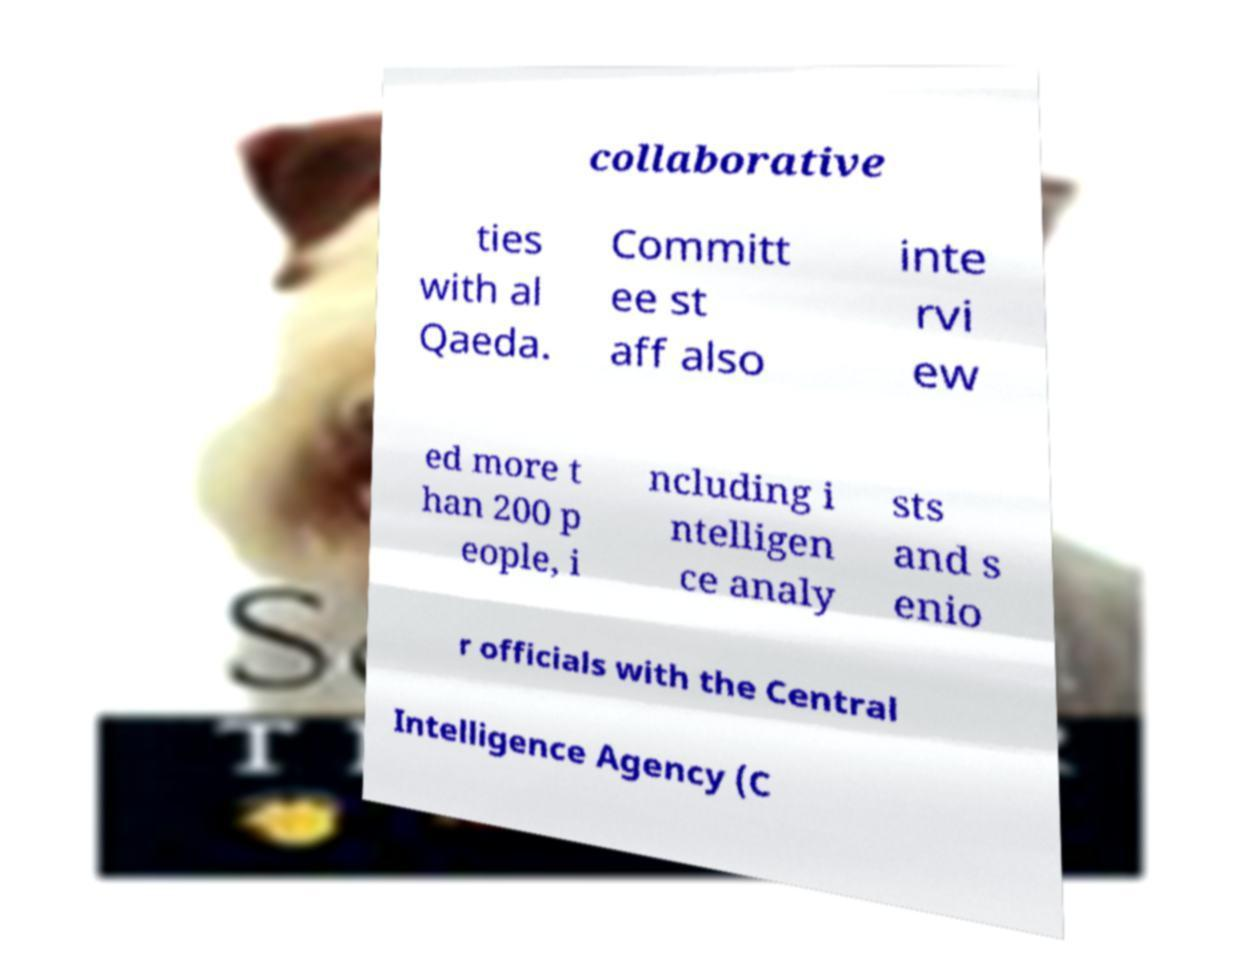Can you accurately transcribe the text from the provided image for me? collaborative ties with al Qaeda. Committ ee st aff also inte rvi ew ed more t han 200 p eople, i ncluding i ntelligen ce analy sts and s enio r officials with the Central Intelligence Agency (C 